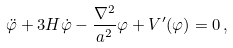<formula> <loc_0><loc_0><loc_500><loc_500>\ddot { \varphi } + 3 H \dot { \varphi } - \frac { \nabla ^ { 2 } } { a ^ { 2 } } \varphi + V ^ { \prime } ( \varphi ) = 0 \, ,</formula> 